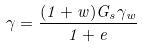Convert formula to latex. <formula><loc_0><loc_0><loc_500><loc_500>\gamma = \frac { ( 1 + w ) G _ { s } \gamma _ { w } } { 1 + e }</formula> 